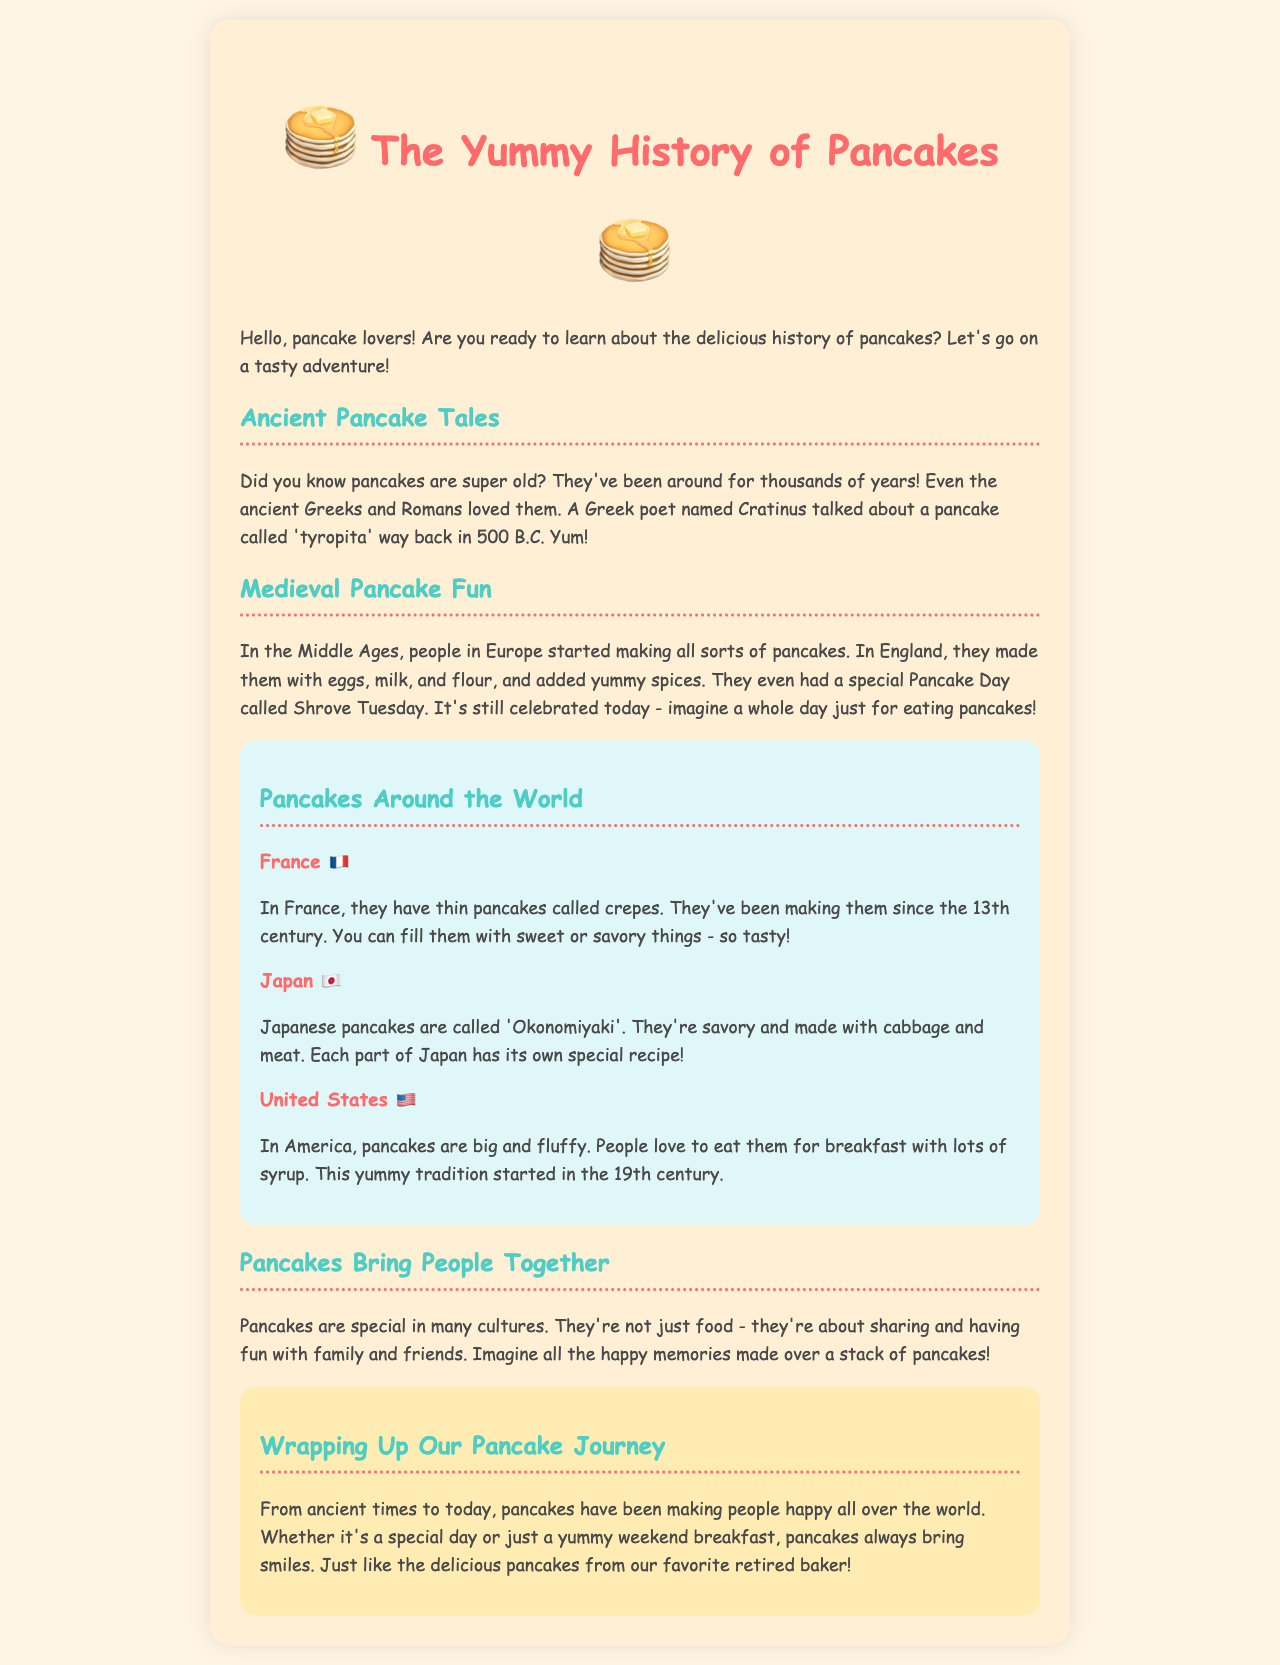What did the Greek poet Cratinus write about? Cratinus wrote about a pancake called 'tyropita'.
Answer: 'tyropita' What is the name of the Japanese pancake? The Japanese pancake is called 'Okonomiyaki'.
Answer: 'Okonomiyaki' When did people in France start making crepes? They started making crepes in the 13th century.
Answer: 13th century What special day is celebrated in England related to pancakes? The special day is called Shrove Tuesday.
Answer: Shrove Tuesday How do American pancakes differ from those in other countries? American pancakes are big and fluffy.
Answer: big and fluffy In which century did the tradition of American pancakes start? The tradition started in the 19th century.
Answer: 19th century What do pancakes symbolize in many cultures? They symbolize sharing and having fun with family and friends.
Answer: sharing and having fun What is a primary theme of the document? The primary theme is about the history and joy of pancakes.
Answer: history and joy of pancakes What type of document is this? This document is a report about pancakes.
Answer: a report 